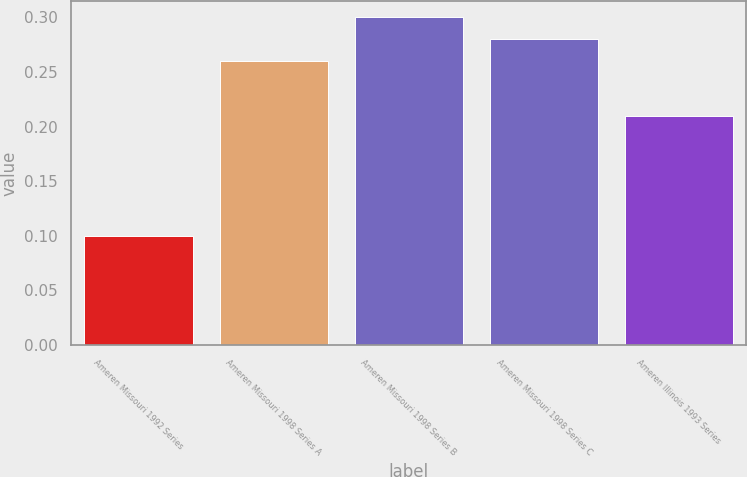Convert chart to OTSL. <chart><loc_0><loc_0><loc_500><loc_500><bar_chart><fcel>Ameren Missouri 1992 Series<fcel>Ameren Missouri 1998 Series A<fcel>Ameren Missouri 1998 Series B<fcel>Ameren Missouri 1998 Series C<fcel>Ameren Illinois 1993 Series<nl><fcel>0.1<fcel>0.26<fcel>0.3<fcel>0.28<fcel>0.21<nl></chart> 